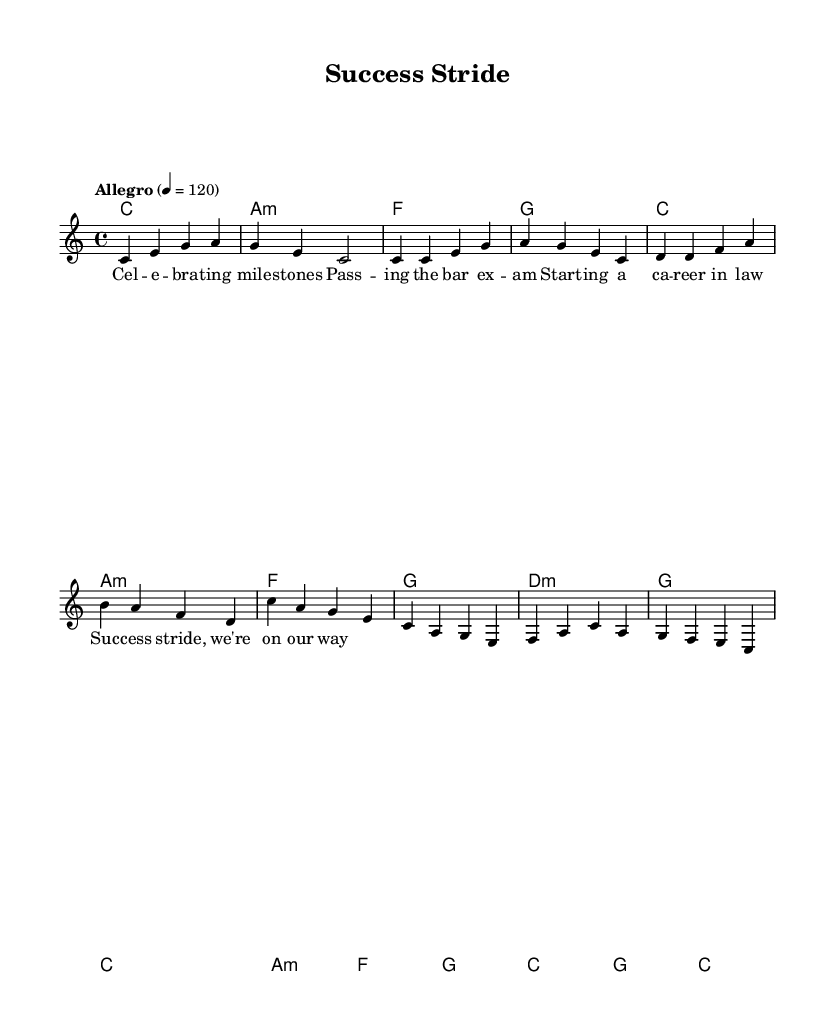What is the key signature of this music? The key signature is C major, which is indicated by the absence of sharps or flats in the key signature.
Answer: C major What is the time signature of this music? The time signature is shown at the beginning of the score. It indicates 4 beats per measure with each quarter note getting one beat.
Answer: 4/4 What is the tempo marking of this piece? The tempo marking "Allegro" indicates a lively tempo, and it specifies that the beat should be played at 120 beats per minute.
Answer: Allegro How many measures are in the chorus section? By examining the chorus notes, we can count the measures. There are 6 distinct measures presented in the chorus.
Answer: 6 What is the primary chord used in the first measure? The first measure shows the chord 'c', which is the primary chord for the introduction.
Answer: c What is the lyrical theme of this piece? The lyrics focus on celebrating milestones and professional achievements, which is reflected in phrases such as "celebrating milestones" and "success stride."
Answer: Celebrating milestones Which harmony follows the 'f' chord in the first verse? By looking at the chord progression in the verse and the order of chords, the harmony that follows the 'f' chord is 'g'.
Answer: g 